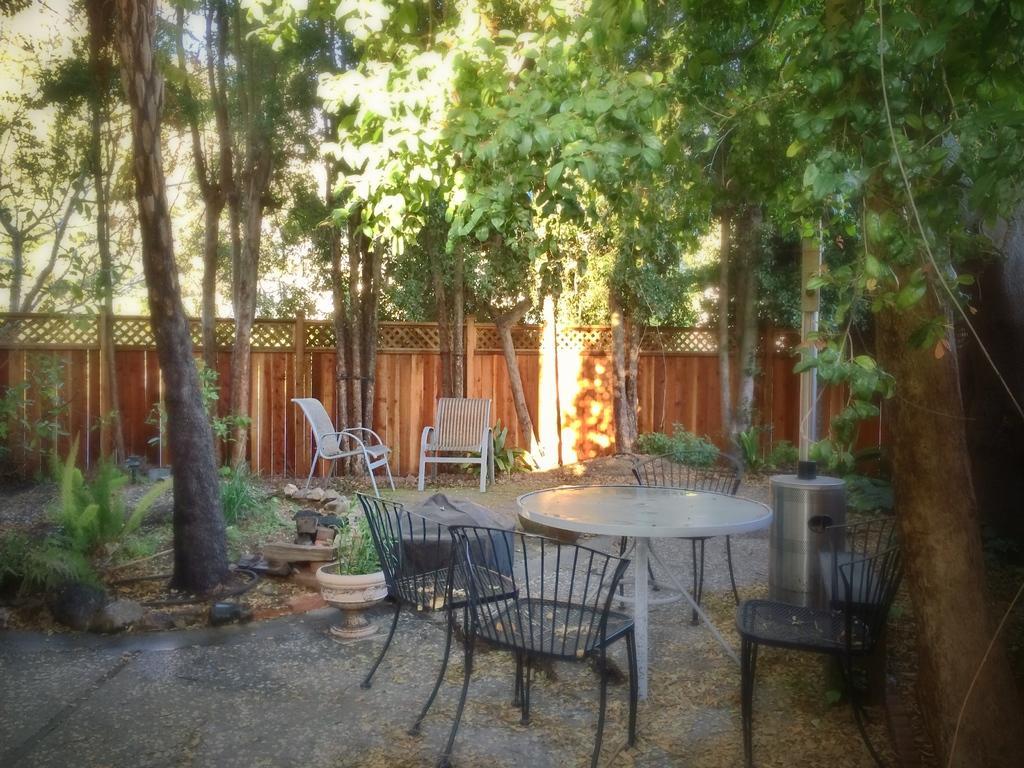Describe this image in one or two sentences. This picture is clicked outside. In the foreground we can see the chairs, table and some other items are placed on the ground and we can see the plants, trees and in the background we can see some other items and the chairs. 